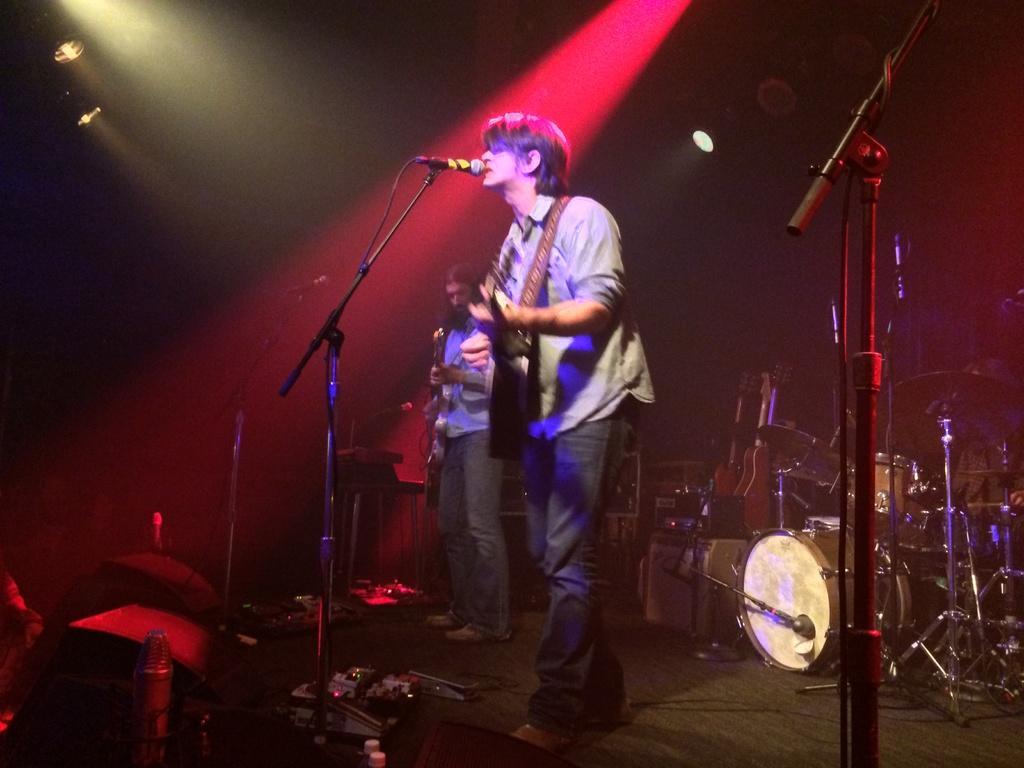How would you summarize this image in a sentence or two? Man playing guitar,here there is microphone and musical instruments. 